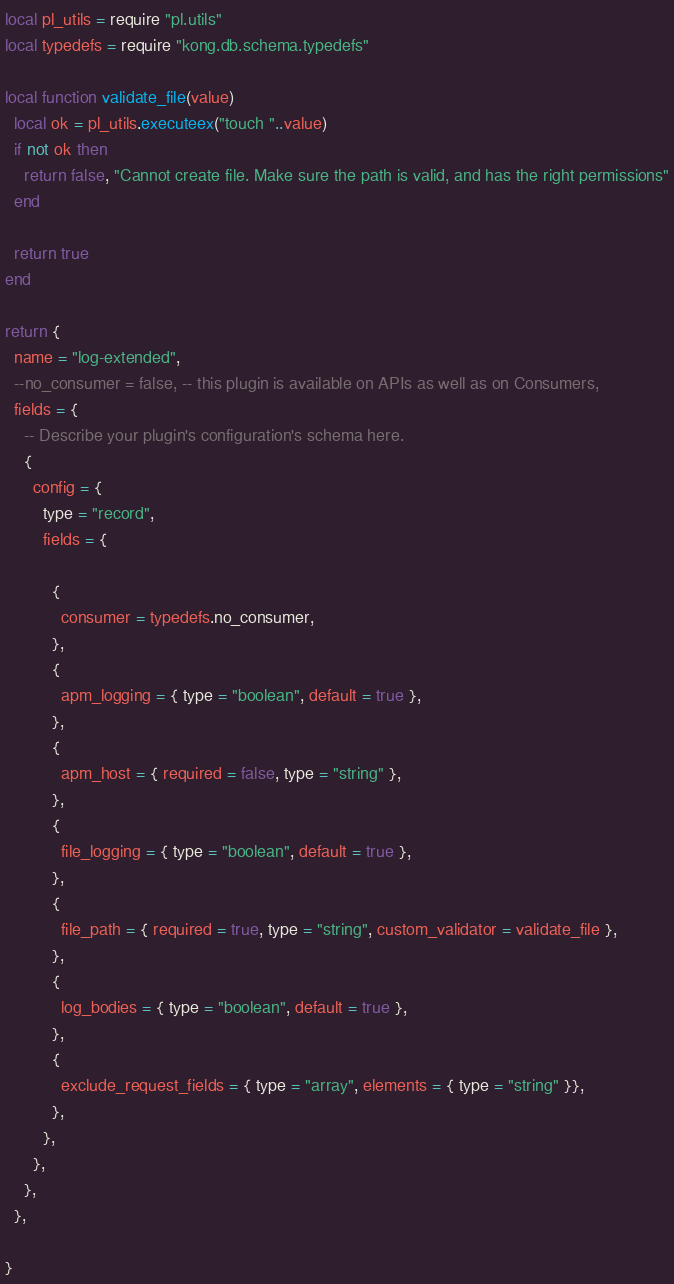<code> <loc_0><loc_0><loc_500><loc_500><_Lua_>local pl_utils = require "pl.utils"
local typedefs = require "kong.db.schema.typedefs"

local function validate_file(value)
  local ok = pl_utils.executeex("touch "..value)
  if not ok then
    return false, "Cannot create file. Make sure the path is valid, and has the right permissions"
  end

  return true
end

return {
  name = "log-extended",
  --no_consumer = false, -- this plugin is available on APIs as well as on Consumers,
  fields = {
    -- Describe your plugin's configuration's schema here.
    {
      config = {
        type = "record",
        fields = {
          
          {
            consumer = typedefs.no_consumer,
          },
          {
            apm_logging = { type = "boolean", default = true },
          },
          {
            apm_host = { required = false, type = "string" },
          },
          {
            file_logging = { type = "boolean", default = true },
          },
          {
            file_path = { required = true, type = "string", custom_validator = validate_file },
          },
          {
            log_bodies = { type = "boolean", default = true },
          },
          {
            exclude_request_fields = { type = "array", elements = { type = "string" }},
          },
        },
      },
    },
  },

}

</code> 